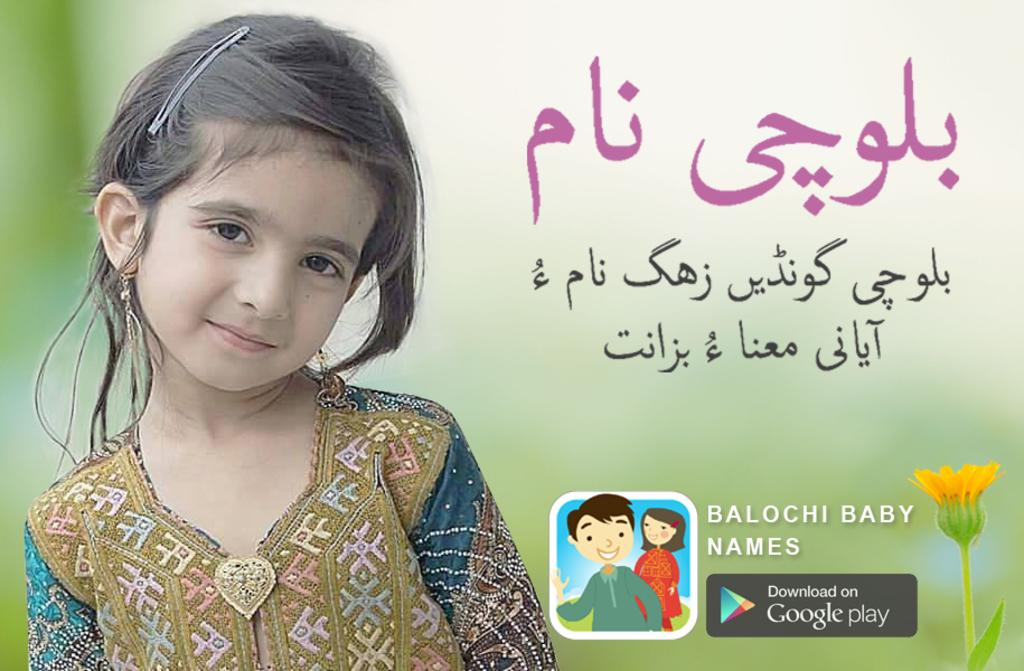What is the main subject of the image? There is a baby in the image. Where is the baby located in the image? The baby is on the left side of the image. How is the baby described? The baby is described as cute. What is the baby wearing? The baby is wearing a dress. What other object can be seen in the image? There is a flower in the image. Where is the flower located in the image? The flower is on the right side of the image. What else is present in the image? There is an animation in the middle of the image. Can you tell me how many friends the baby has in the image? There is no indication of friends in the image; it only shows a baby, a flower, and an animation. Is there a donkey present in the image? No, there is no donkey present in the image. 